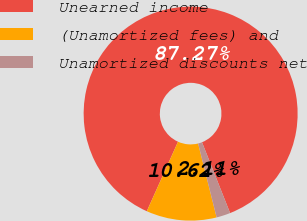Convert chart. <chart><loc_0><loc_0><loc_500><loc_500><pie_chart><fcel>Unearned income<fcel>(Unamortized fees) and<fcel>Unamortized discounts net<nl><fcel>87.27%<fcel>10.62%<fcel>2.11%<nl></chart> 